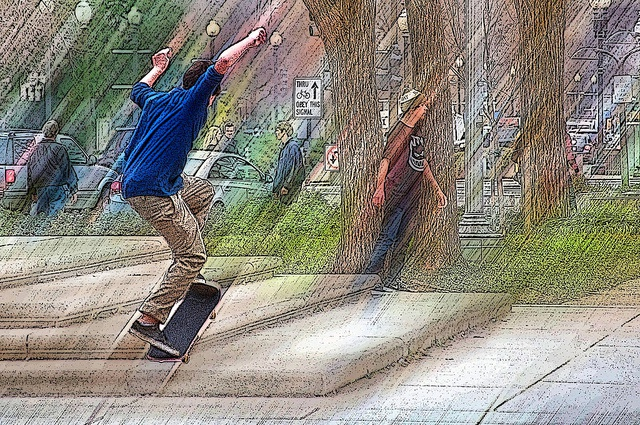Describe the objects in this image and their specific colors. I can see people in tan, black, navy, and gray tones, people in tan, black, gray, brown, and maroon tones, car in tan, darkgray, gray, and black tones, car in tan, darkgray, gray, lightgray, and black tones, and people in tan, black, gray, blue, and navy tones in this image. 